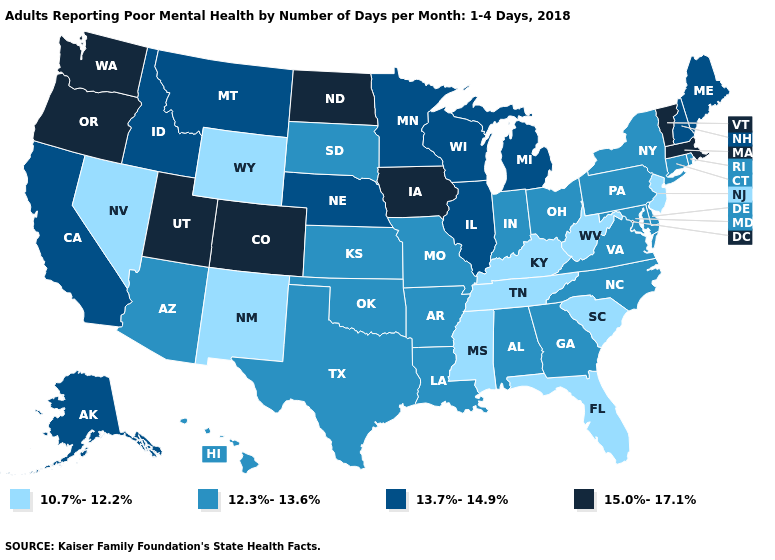Does Illinois have a higher value than Rhode Island?
Short answer required. Yes. What is the value of Ohio?
Concise answer only. 12.3%-13.6%. Name the states that have a value in the range 13.7%-14.9%?
Give a very brief answer. Alaska, California, Idaho, Illinois, Maine, Michigan, Minnesota, Montana, Nebraska, New Hampshire, Wisconsin. What is the highest value in the MidWest ?
Give a very brief answer. 15.0%-17.1%. Among the states that border California , which have the highest value?
Write a very short answer. Oregon. Name the states that have a value in the range 12.3%-13.6%?
Give a very brief answer. Alabama, Arizona, Arkansas, Connecticut, Delaware, Georgia, Hawaii, Indiana, Kansas, Louisiana, Maryland, Missouri, New York, North Carolina, Ohio, Oklahoma, Pennsylvania, Rhode Island, South Dakota, Texas, Virginia. Does the first symbol in the legend represent the smallest category?
Keep it brief. Yes. Name the states that have a value in the range 10.7%-12.2%?
Give a very brief answer. Florida, Kentucky, Mississippi, Nevada, New Jersey, New Mexico, South Carolina, Tennessee, West Virginia, Wyoming. Is the legend a continuous bar?
Concise answer only. No. Among the states that border North Dakota , which have the highest value?
Be succinct. Minnesota, Montana. Name the states that have a value in the range 15.0%-17.1%?
Write a very short answer. Colorado, Iowa, Massachusetts, North Dakota, Oregon, Utah, Vermont, Washington. Which states hav the highest value in the Northeast?
Keep it brief. Massachusetts, Vermont. Which states have the highest value in the USA?
Answer briefly. Colorado, Iowa, Massachusetts, North Dakota, Oregon, Utah, Vermont, Washington. Does the first symbol in the legend represent the smallest category?
Give a very brief answer. Yes. What is the lowest value in states that border Colorado?
Keep it brief. 10.7%-12.2%. 